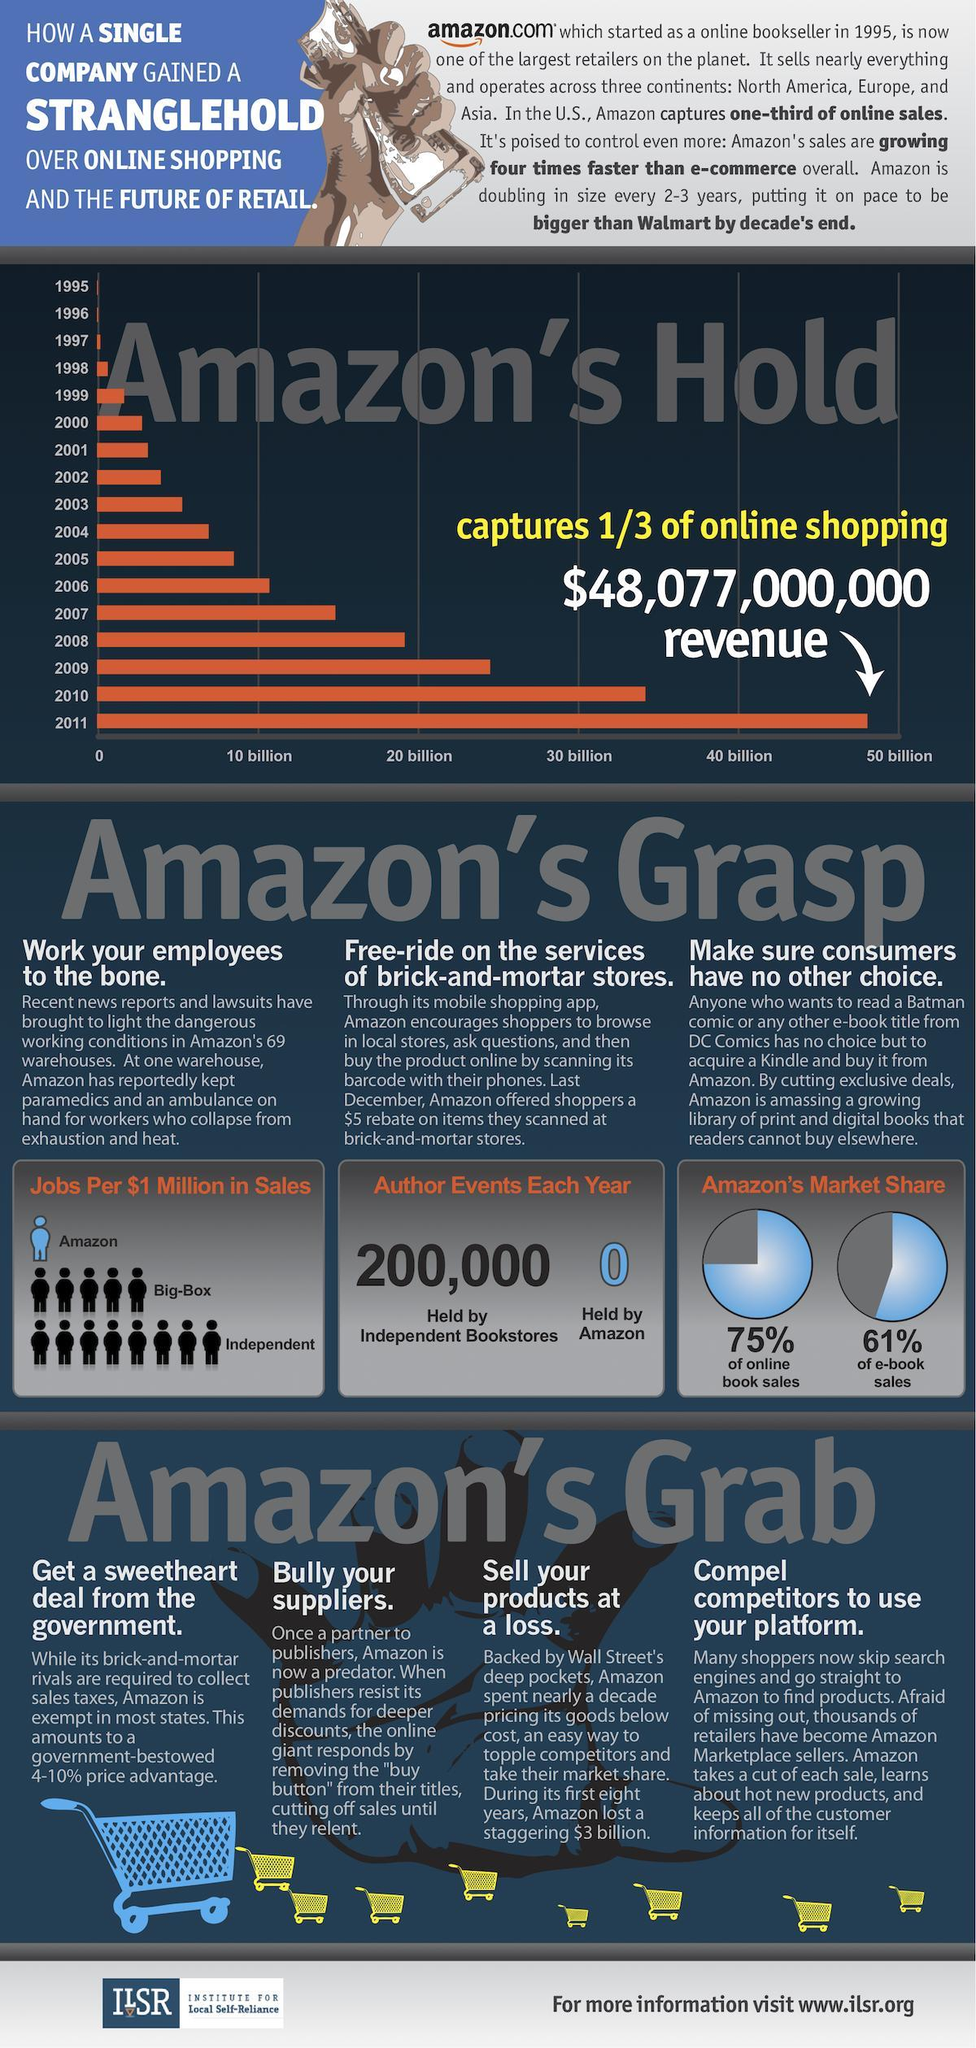In which year, amazon's online shopping generated revenue above $40 billion?
Answer the question with a short phrase. 2011 How many jobs were created by amazon per $1 million in sales? 1 How many author events are held by independent bookstores each year? 200,000 What is the amazon's market share in e-book sales? 61% How many author events are held by amazon each year? 0 What is the amazon's market share in online book sales? 75% How many jobs were created by Big-Box per $1 million in sales? 5 